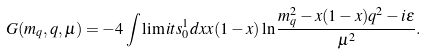Convert formula to latex. <formula><loc_0><loc_0><loc_500><loc_500>G ( m _ { q } , q , \mu ) = - 4 \int \lim i t s _ { 0 } ^ { 1 } d x x ( 1 - x ) \ln \frac { m _ { q } ^ { 2 } - x ( 1 - x ) q ^ { 2 } - i \epsilon } { \mu ^ { 2 } } .</formula> 